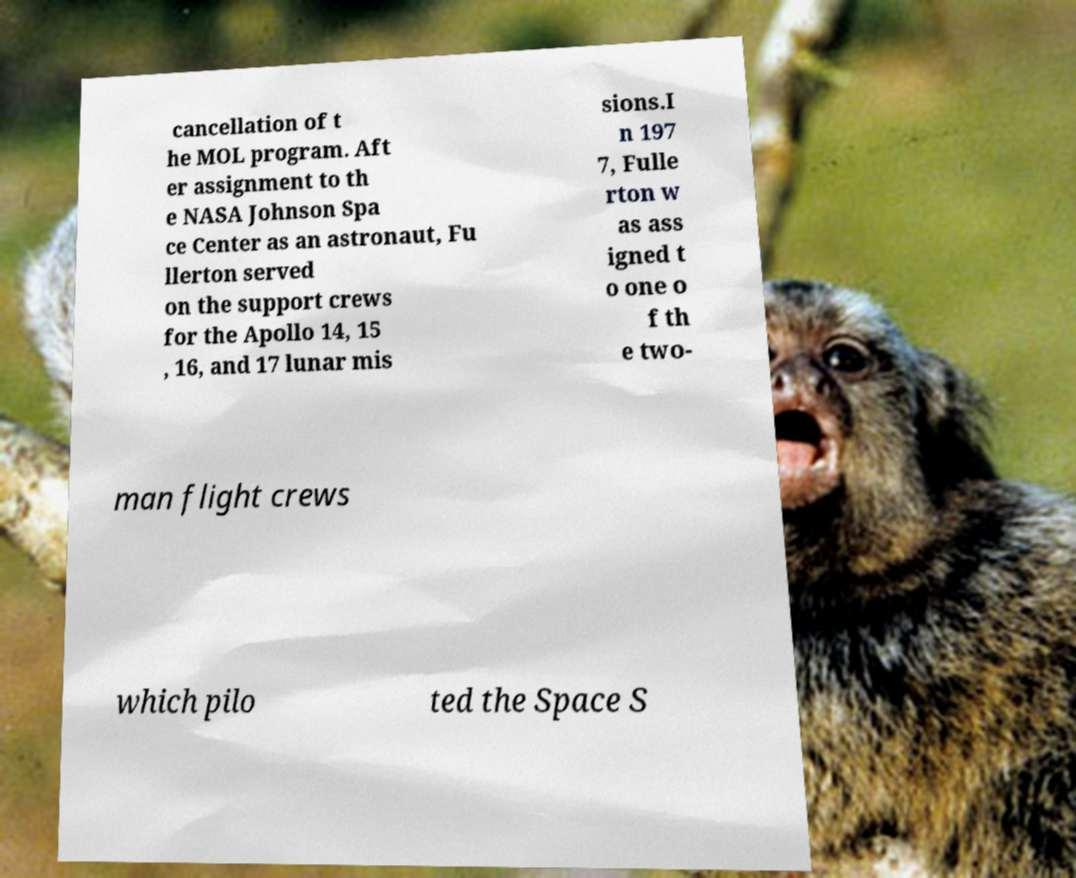For documentation purposes, I need the text within this image transcribed. Could you provide that? cancellation of t he MOL program. Aft er assignment to th e NASA Johnson Spa ce Center as an astronaut, Fu llerton served on the support crews for the Apollo 14, 15 , 16, and 17 lunar mis sions.I n 197 7, Fulle rton w as ass igned t o one o f th e two- man flight crews which pilo ted the Space S 